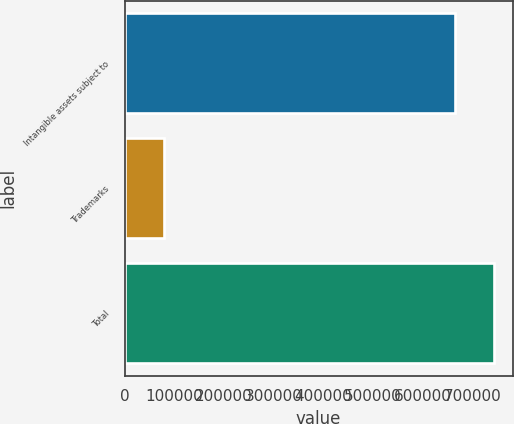Convert chart. <chart><loc_0><loc_0><loc_500><loc_500><bar_chart><fcel>Intangible assets subject to<fcel>Trademarks<fcel>Total<nl><fcel>664969<fcel>78800<fcel>743769<nl></chart> 